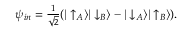<formula> <loc_0><loc_0><loc_500><loc_500>\psi _ { i n } = { \frac { 1 } { \sqrt { 2 } } } ( | \uparrow _ { A } \rangle | \downarrow _ { B } \rangle - | \downarrow _ { A } \rangle | \uparrow _ { B } \rangle ) .</formula> 